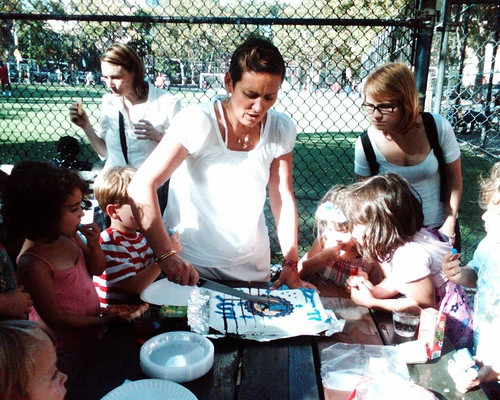Describe the objects in this image and their specific colors. I can see dining table in olive, black, white, lightblue, and darkgray tones, people in olive, white, darkgray, black, and brown tones, people in olive, black, maroon, and brown tones, people in olive, white, black, darkgray, and maroon tones, and people in olive, black, maroon, gray, and white tones in this image. 